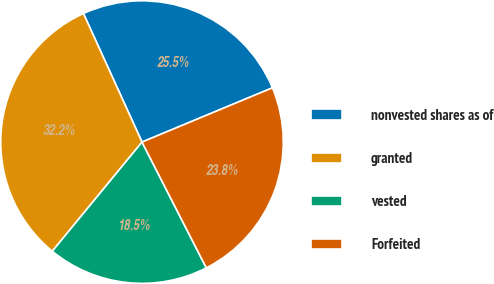Convert chart to OTSL. <chart><loc_0><loc_0><loc_500><loc_500><pie_chart><fcel>nonvested shares as of<fcel>granted<fcel>vested<fcel>Forfeited<nl><fcel>25.53%<fcel>32.24%<fcel>18.47%<fcel>23.75%<nl></chart> 